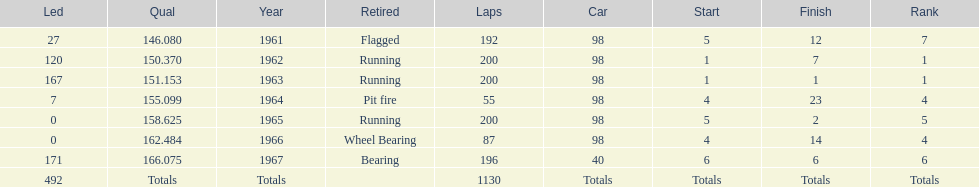What is the difference between the qualfying time in 1967 and 1965? 7.45. 